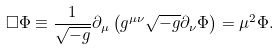<formula> <loc_0><loc_0><loc_500><loc_500>\Box \Phi \equiv \frac { 1 } { \sqrt { - g } } \partial _ { \mu } \left ( g ^ { \mu \nu } \sqrt { - g } \partial _ { \nu } \Phi \right ) = \mu ^ { 2 } \Phi .</formula> 